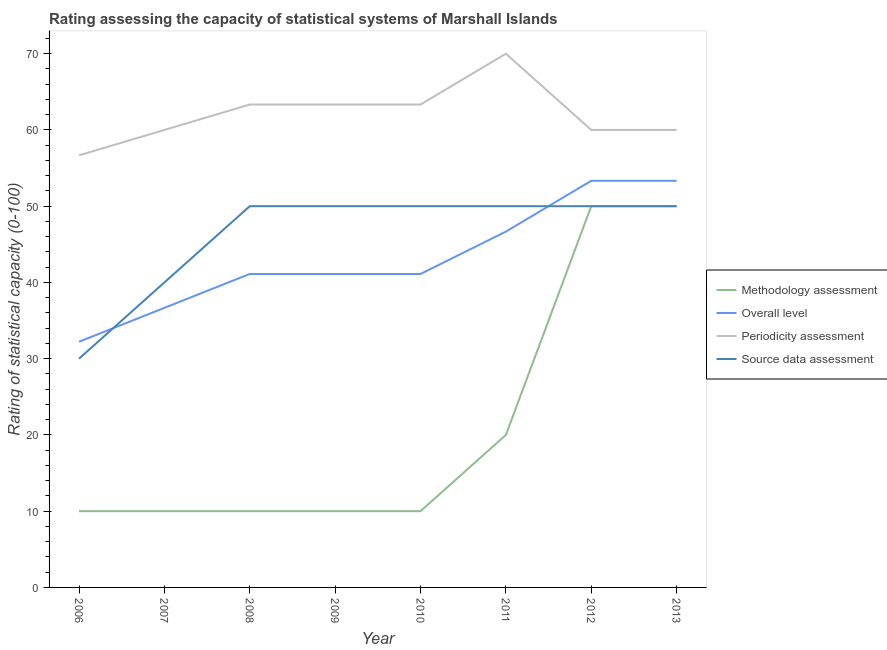Does the line corresponding to methodology assessment rating intersect with the line corresponding to overall level rating?
Ensure brevity in your answer.  No. Is the number of lines equal to the number of legend labels?
Your response must be concise. Yes. What is the source data assessment rating in 2009?
Your response must be concise. 50. Across all years, what is the maximum source data assessment rating?
Provide a short and direct response. 50. Across all years, what is the minimum methodology assessment rating?
Your answer should be very brief. 10. In which year was the source data assessment rating maximum?
Ensure brevity in your answer.  2008. In which year was the periodicity assessment rating minimum?
Offer a terse response. 2006. What is the total overall level rating in the graph?
Your answer should be very brief. 345.56. What is the difference between the overall level rating in 2008 and the periodicity assessment rating in 2010?
Provide a succinct answer. -22.22. What is the average periodicity assessment rating per year?
Give a very brief answer. 62.08. In the year 2007, what is the difference between the source data assessment rating and methodology assessment rating?
Offer a very short reply. 30. What is the ratio of the overall level rating in 2010 to that in 2013?
Offer a terse response. 0.77. Is the overall level rating in 2008 less than that in 2011?
Make the answer very short. Yes. Is the difference between the overall level rating in 2009 and 2012 greater than the difference between the source data assessment rating in 2009 and 2012?
Your response must be concise. No. What is the difference between the highest and the second highest overall level rating?
Your answer should be very brief. 0. What is the difference between the highest and the lowest methodology assessment rating?
Provide a short and direct response. 40. In how many years, is the source data assessment rating greater than the average source data assessment rating taken over all years?
Offer a terse response. 6. Is it the case that in every year, the sum of the overall level rating and periodicity assessment rating is greater than the sum of methodology assessment rating and source data assessment rating?
Offer a terse response. No. How many years are there in the graph?
Your answer should be compact. 8. What is the difference between two consecutive major ticks on the Y-axis?
Ensure brevity in your answer.  10. Are the values on the major ticks of Y-axis written in scientific E-notation?
Make the answer very short. No. Does the graph contain grids?
Provide a short and direct response. No. How are the legend labels stacked?
Provide a short and direct response. Vertical. What is the title of the graph?
Offer a very short reply. Rating assessing the capacity of statistical systems of Marshall Islands. Does "Structural Policies" appear as one of the legend labels in the graph?
Ensure brevity in your answer.  No. What is the label or title of the X-axis?
Make the answer very short. Year. What is the label or title of the Y-axis?
Offer a very short reply. Rating of statistical capacity (0-100). What is the Rating of statistical capacity (0-100) of Overall level in 2006?
Offer a very short reply. 32.22. What is the Rating of statistical capacity (0-100) of Periodicity assessment in 2006?
Ensure brevity in your answer.  56.67. What is the Rating of statistical capacity (0-100) of Overall level in 2007?
Your answer should be very brief. 36.67. What is the Rating of statistical capacity (0-100) of Overall level in 2008?
Make the answer very short. 41.11. What is the Rating of statistical capacity (0-100) in Periodicity assessment in 2008?
Give a very brief answer. 63.33. What is the Rating of statistical capacity (0-100) in Source data assessment in 2008?
Your answer should be very brief. 50. What is the Rating of statistical capacity (0-100) of Methodology assessment in 2009?
Your response must be concise. 10. What is the Rating of statistical capacity (0-100) in Overall level in 2009?
Ensure brevity in your answer.  41.11. What is the Rating of statistical capacity (0-100) of Periodicity assessment in 2009?
Provide a succinct answer. 63.33. What is the Rating of statistical capacity (0-100) in Source data assessment in 2009?
Your answer should be compact. 50. What is the Rating of statistical capacity (0-100) in Methodology assessment in 2010?
Provide a short and direct response. 10. What is the Rating of statistical capacity (0-100) of Overall level in 2010?
Ensure brevity in your answer.  41.11. What is the Rating of statistical capacity (0-100) of Periodicity assessment in 2010?
Provide a succinct answer. 63.33. What is the Rating of statistical capacity (0-100) in Overall level in 2011?
Provide a short and direct response. 46.67. What is the Rating of statistical capacity (0-100) in Periodicity assessment in 2011?
Your response must be concise. 70. What is the Rating of statistical capacity (0-100) of Source data assessment in 2011?
Provide a succinct answer. 50. What is the Rating of statistical capacity (0-100) of Overall level in 2012?
Ensure brevity in your answer.  53.33. What is the Rating of statistical capacity (0-100) in Overall level in 2013?
Your answer should be compact. 53.33. What is the Rating of statistical capacity (0-100) in Source data assessment in 2013?
Give a very brief answer. 50. Across all years, what is the maximum Rating of statistical capacity (0-100) of Methodology assessment?
Give a very brief answer. 50. Across all years, what is the maximum Rating of statistical capacity (0-100) of Overall level?
Your response must be concise. 53.33. Across all years, what is the maximum Rating of statistical capacity (0-100) of Periodicity assessment?
Your answer should be compact. 70. Across all years, what is the minimum Rating of statistical capacity (0-100) in Overall level?
Provide a succinct answer. 32.22. Across all years, what is the minimum Rating of statistical capacity (0-100) of Periodicity assessment?
Offer a very short reply. 56.67. What is the total Rating of statistical capacity (0-100) of Methodology assessment in the graph?
Your response must be concise. 170. What is the total Rating of statistical capacity (0-100) of Overall level in the graph?
Keep it short and to the point. 345.56. What is the total Rating of statistical capacity (0-100) in Periodicity assessment in the graph?
Offer a very short reply. 496.67. What is the total Rating of statistical capacity (0-100) in Source data assessment in the graph?
Give a very brief answer. 370. What is the difference between the Rating of statistical capacity (0-100) in Overall level in 2006 and that in 2007?
Your answer should be very brief. -4.44. What is the difference between the Rating of statistical capacity (0-100) of Periodicity assessment in 2006 and that in 2007?
Offer a terse response. -3.33. What is the difference between the Rating of statistical capacity (0-100) in Source data assessment in 2006 and that in 2007?
Ensure brevity in your answer.  -10. What is the difference between the Rating of statistical capacity (0-100) in Overall level in 2006 and that in 2008?
Provide a succinct answer. -8.89. What is the difference between the Rating of statistical capacity (0-100) in Periodicity assessment in 2006 and that in 2008?
Your response must be concise. -6.67. What is the difference between the Rating of statistical capacity (0-100) in Methodology assessment in 2006 and that in 2009?
Provide a short and direct response. 0. What is the difference between the Rating of statistical capacity (0-100) in Overall level in 2006 and that in 2009?
Offer a very short reply. -8.89. What is the difference between the Rating of statistical capacity (0-100) of Periodicity assessment in 2006 and that in 2009?
Your answer should be compact. -6.67. What is the difference between the Rating of statistical capacity (0-100) in Methodology assessment in 2006 and that in 2010?
Give a very brief answer. 0. What is the difference between the Rating of statistical capacity (0-100) in Overall level in 2006 and that in 2010?
Offer a very short reply. -8.89. What is the difference between the Rating of statistical capacity (0-100) of Periodicity assessment in 2006 and that in 2010?
Keep it short and to the point. -6.67. What is the difference between the Rating of statistical capacity (0-100) of Source data assessment in 2006 and that in 2010?
Keep it short and to the point. -20. What is the difference between the Rating of statistical capacity (0-100) of Methodology assessment in 2006 and that in 2011?
Your answer should be compact. -10. What is the difference between the Rating of statistical capacity (0-100) in Overall level in 2006 and that in 2011?
Offer a terse response. -14.44. What is the difference between the Rating of statistical capacity (0-100) in Periodicity assessment in 2006 and that in 2011?
Provide a short and direct response. -13.33. What is the difference between the Rating of statistical capacity (0-100) of Source data assessment in 2006 and that in 2011?
Keep it short and to the point. -20. What is the difference between the Rating of statistical capacity (0-100) of Methodology assessment in 2006 and that in 2012?
Ensure brevity in your answer.  -40. What is the difference between the Rating of statistical capacity (0-100) of Overall level in 2006 and that in 2012?
Make the answer very short. -21.11. What is the difference between the Rating of statistical capacity (0-100) of Source data assessment in 2006 and that in 2012?
Your response must be concise. -20. What is the difference between the Rating of statistical capacity (0-100) in Overall level in 2006 and that in 2013?
Make the answer very short. -21.11. What is the difference between the Rating of statistical capacity (0-100) in Periodicity assessment in 2006 and that in 2013?
Offer a very short reply. -3.33. What is the difference between the Rating of statistical capacity (0-100) in Overall level in 2007 and that in 2008?
Keep it short and to the point. -4.44. What is the difference between the Rating of statistical capacity (0-100) of Periodicity assessment in 2007 and that in 2008?
Ensure brevity in your answer.  -3.33. What is the difference between the Rating of statistical capacity (0-100) of Methodology assessment in 2007 and that in 2009?
Give a very brief answer. 0. What is the difference between the Rating of statistical capacity (0-100) of Overall level in 2007 and that in 2009?
Your answer should be compact. -4.44. What is the difference between the Rating of statistical capacity (0-100) of Periodicity assessment in 2007 and that in 2009?
Offer a terse response. -3.33. What is the difference between the Rating of statistical capacity (0-100) of Source data assessment in 2007 and that in 2009?
Your answer should be very brief. -10. What is the difference between the Rating of statistical capacity (0-100) in Overall level in 2007 and that in 2010?
Your response must be concise. -4.44. What is the difference between the Rating of statistical capacity (0-100) of Periodicity assessment in 2007 and that in 2010?
Your answer should be very brief. -3.33. What is the difference between the Rating of statistical capacity (0-100) in Source data assessment in 2007 and that in 2010?
Provide a short and direct response. -10. What is the difference between the Rating of statistical capacity (0-100) of Overall level in 2007 and that in 2011?
Your answer should be very brief. -10. What is the difference between the Rating of statistical capacity (0-100) in Periodicity assessment in 2007 and that in 2011?
Keep it short and to the point. -10. What is the difference between the Rating of statistical capacity (0-100) in Source data assessment in 2007 and that in 2011?
Give a very brief answer. -10. What is the difference between the Rating of statistical capacity (0-100) of Overall level in 2007 and that in 2012?
Your answer should be compact. -16.67. What is the difference between the Rating of statistical capacity (0-100) of Periodicity assessment in 2007 and that in 2012?
Your answer should be compact. 0. What is the difference between the Rating of statistical capacity (0-100) in Overall level in 2007 and that in 2013?
Keep it short and to the point. -16.67. What is the difference between the Rating of statistical capacity (0-100) of Methodology assessment in 2008 and that in 2009?
Provide a succinct answer. 0. What is the difference between the Rating of statistical capacity (0-100) of Source data assessment in 2008 and that in 2009?
Your response must be concise. 0. What is the difference between the Rating of statistical capacity (0-100) in Methodology assessment in 2008 and that in 2011?
Give a very brief answer. -10. What is the difference between the Rating of statistical capacity (0-100) in Overall level in 2008 and that in 2011?
Provide a short and direct response. -5.56. What is the difference between the Rating of statistical capacity (0-100) of Periodicity assessment in 2008 and that in 2011?
Ensure brevity in your answer.  -6.67. What is the difference between the Rating of statistical capacity (0-100) in Source data assessment in 2008 and that in 2011?
Ensure brevity in your answer.  0. What is the difference between the Rating of statistical capacity (0-100) in Methodology assessment in 2008 and that in 2012?
Your answer should be very brief. -40. What is the difference between the Rating of statistical capacity (0-100) in Overall level in 2008 and that in 2012?
Make the answer very short. -12.22. What is the difference between the Rating of statistical capacity (0-100) of Overall level in 2008 and that in 2013?
Your answer should be compact. -12.22. What is the difference between the Rating of statistical capacity (0-100) of Periodicity assessment in 2008 and that in 2013?
Your response must be concise. 3.33. What is the difference between the Rating of statistical capacity (0-100) in Source data assessment in 2008 and that in 2013?
Ensure brevity in your answer.  0. What is the difference between the Rating of statistical capacity (0-100) in Overall level in 2009 and that in 2010?
Give a very brief answer. 0. What is the difference between the Rating of statistical capacity (0-100) in Methodology assessment in 2009 and that in 2011?
Your answer should be very brief. -10. What is the difference between the Rating of statistical capacity (0-100) in Overall level in 2009 and that in 2011?
Provide a succinct answer. -5.56. What is the difference between the Rating of statistical capacity (0-100) in Periodicity assessment in 2009 and that in 2011?
Provide a short and direct response. -6.67. What is the difference between the Rating of statistical capacity (0-100) of Overall level in 2009 and that in 2012?
Your response must be concise. -12.22. What is the difference between the Rating of statistical capacity (0-100) in Periodicity assessment in 2009 and that in 2012?
Give a very brief answer. 3.33. What is the difference between the Rating of statistical capacity (0-100) in Methodology assessment in 2009 and that in 2013?
Ensure brevity in your answer.  -40. What is the difference between the Rating of statistical capacity (0-100) in Overall level in 2009 and that in 2013?
Make the answer very short. -12.22. What is the difference between the Rating of statistical capacity (0-100) in Source data assessment in 2009 and that in 2013?
Offer a very short reply. 0. What is the difference between the Rating of statistical capacity (0-100) of Methodology assessment in 2010 and that in 2011?
Offer a very short reply. -10. What is the difference between the Rating of statistical capacity (0-100) in Overall level in 2010 and that in 2011?
Offer a very short reply. -5.56. What is the difference between the Rating of statistical capacity (0-100) in Periodicity assessment in 2010 and that in 2011?
Your response must be concise. -6.67. What is the difference between the Rating of statistical capacity (0-100) of Source data assessment in 2010 and that in 2011?
Your answer should be very brief. 0. What is the difference between the Rating of statistical capacity (0-100) in Overall level in 2010 and that in 2012?
Provide a short and direct response. -12.22. What is the difference between the Rating of statistical capacity (0-100) in Periodicity assessment in 2010 and that in 2012?
Offer a very short reply. 3.33. What is the difference between the Rating of statistical capacity (0-100) of Source data assessment in 2010 and that in 2012?
Your response must be concise. 0. What is the difference between the Rating of statistical capacity (0-100) of Methodology assessment in 2010 and that in 2013?
Offer a very short reply. -40. What is the difference between the Rating of statistical capacity (0-100) in Overall level in 2010 and that in 2013?
Provide a short and direct response. -12.22. What is the difference between the Rating of statistical capacity (0-100) in Periodicity assessment in 2010 and that in 2013?
Provide a short and direct response. 3.33. What is the difference between the Rating of statistical capacity (0-100) in Overall level in 2011 and that in 2012?
Offer a very short reply. -6.67. What is the difference between the Rating of statistical capacity (0-100) in Source data assessment in 2011 and that in 2012?
Make the answer very short. 0. What is the difference between the Rating of statistical capacity (0-100) in Methodology assessment in 2011 and that in 2013?
Offer a terse response. -30. What is the difference between the Rating of statistical capacity (0-100) of Overall level in 2011 and that in 2013?
Your answer should be very brief. -6.67. What is the difference between the Rating of statistical capacity (0-100) of Source data assessment in 2012 and that in 2013?
Your answer should be very brief. 0. What is the difference between the Rating of statistical capacity (0-100) of Methodology assessment in 2006 and the Rating of statistical capacity (0-100) of Overall level in 2007?
Keep it short and to the point. -26.67. What is the difference between the Rating of statistical capacity (0-100) of Methodology assessment in 2006 and the Rating of statistical capacity (0-100) of Periodicity assessment in 2007?
Provide a short and direct response. -50. What is the difference between the Rating of statistical capacity (0-100) in Methodology assessment in 2006 and the Rating of statistical capacity (0-100) in Source data assessment in 2007?
Provide a succinct answer. -30. What is the difference between the Rating of statistical capacity (0-100) of Overall level in 2006 and the Rating of statistical capacity (0-100) of Periodicity assessment in 2007?
Make the answer very short. -27.78. What is the difference between the Rating of statistical capacity (0-100) in Overall level in 2006 and the Rating of statistical capacity (0-100) in Source data assessment in 2007?
Ensure brevity in your answer.  -7.78. What is the difference between the Rating of statistical capacity (0-100) of Periodicity assessment in 2006 and the Rating of statistical capacity (0-100) of Source data assessment in 2007?
Your answer should be compact. 16.67. What is the difference between the Rating of statistical capacity (0-100) of Methodology assessment in 2006 and the Rating of statistical capacity (0-100) of Overall level in 2008?
Your answer should be very brief. -31.11. What is the difference between the Rating of statistical capacity (0-100) of Methodology assessment in 2006 and the Rating of statistical capacity (0-100) of Periodicity assessment in 2008?
Offer a very short reply. -53.33. What is the difference between the Rating of statistical capacity (0-100) in Overall level in 2006 and the Rating of statistical capacity (0-100) in Periodicity assessment in 2008?
Ensure brevity in your answer.  -31.11. What is the difference between the Rating of statistical capacity (0-100) in Overall level in 2006 and the Rating of statistical capacity (0-100) in Source data assessment in 2008?
Provide a short and direct response. -17.78. What is the difference between the Rating of statistical capacity (0-100) of Methodology assessment in 2006 and the Rating of statistical capacity (0-100) of Overall level in 2009?
Offer a terse response. -31.11. What is the difference between the Rating of statistical capacity (0-100) in Methodology assessment in 2006 and the Rating of statistical capacity (0-100) in Periodicity assessment in 2009?
Offer a very short reply. -53.33. What is the difference between the Rating of statistical capacity (0-100) of Methodology assessment in 2006 and the Rating of statistical capacity (0-100) of Source data assessment in 2009?
Your answer should be very brief. -40. What is the difference between the Rating of statistical capacity (0-100) of Overall level in 2006 and the Rating of statistical capacity (0-100) of Periodicity assessment in 2009?
Your answer should be very brief. -31.11. What is the difference between the Rating of statistical capacity (0-100) of Overall level in 2006 and the Rating of statistical capacity (0-100) of Source data assessment in 2009?
Your answer should be compact. -17.78. What is the difference between the Rating of statistical capacity (0-100) in Methodology assessment in 2006 and the Rating of statistical capacity (0-100) in Overall level in 2010?
Keep it short and to the point. -31.11. What is the difference between the Rating of statistical capacity (0-100) of Methodology assessment in 2006 and the Rating of statistical capacity (0-100) of Periodicity assessment in 2010?
Your answer should be very brief. -53.33. What is the difference between the Rating of statistical capacity (0-100) in Methodology assessment in 2006 and the Rating of statistical capacity (0-100) in Source data assessment in 2010?
Give a very brief answer. -40. What is the difference between the Rating of statistical capacity (0-100) of Overall level in 2006 and the Rating of statistical capacity (0-100) of Periodicity assessment in 2010?
Keep it short and to the point. -31.11. What is the difference between the Rating of statistical capacity (0-100) of Overall level in 2006 and the Rating of statistical capacity (0-100) of Source data assessment in 2010?
Offer a very short reply. -17.78. What is the difference between the Rating of statistical capacity (0-100) of Periodicity assessment in 2006 and the Rating of statistical capacity (0-100) of Source data assessment in 2010?
Your answer should be very brief. 6.67. What is the difference between the Rating of statistical capacity (0-100) in Methodology assessment in 2006 and the Rating of statistical capacity (0-100) in Overall level in 2011?
Provide a short and direct response. -36.67. What is the difference between the Rating of statistical capacity (0-100) of Methodology assessment in 2006 and the Rating of statistical capacity (0-100) of Periodicity assessment in 2011?
Offer a terse response. -60. What is the difference between the Rating of statistical capacity (0-100) in Overall level in 2006 and the Rating of statistical capacity (0-100) in Periodicity assessment in 2011?
Ensure brevity in your answer.  -37.78. What is the difference between the Rating of statistical capacity (0-100) of Overall level in 2006 and the Rating of statistical capacity (0-100) of Source data assessment in 2011?
Make the answer very short. -17.78. What is the difference between the Rating of statistical capacity (0-100) of Periodicity assessment in 2006 and the Rating of statistical capacity (0-100) of Source data assessment in 2011?
Give a very brief answer. 6.67. What is the difference between the Rating of statistical capacity (0-100) in Methodology assessment in 2006 and the Rating of statistical capacity (0-100) in Overall level in 2012?
Keep it short and to the point. -43.33. What is the difference between the Rating of statistical capacity (0-100) in Methodology assessment in 2006 and the Rating of statistical capacity (0-100) in Periodicity assessment in 2012?
Ensure brevity in your answer.  -50. What is the difference between the Rating of statistical capacity (0-100) of Methodology assessment in 2006 and the Rating of statistical capacity (0-100) of Source data assessment in 2012?
Offer a terse response. -40. What is the difference between the Rating of statistical capacity (0-100) of Overall level in 2006 and the Rating of statistical capacity (0-100) of Periodicity assessment in 2012?
Your answer should be very brief. -27.78. What is the difference between the Rating of statistical capacity (0-100) in Overall level in 2006 and the Rating of statistical capacity (0-100) in Source data assessment in 2012?
Provide a succinct answer. -17.78. What is the difference between the Rating of statistical capacity (0-100) of Periodicity assessment in 2006 and the Rating of statistical capacity (0-100) of Source data assessment in 2012?
Provide a succinct answer. 6.67. What is the difference between the Rating of statistical capacity (0-100) in Methodology assessment in 2006 and the Rating of statistical capacity (0-100) in Overall level in 2013?
Your answer should be compact. -43.33. What is the difference between the Rating of statistical capacity (0-100) in Methodology assessment in 2006 and the Rating of statistical capacity (0-100) in Source data assessment in 2013?
Provide a short and direct response. -40. What is the difference between the Rating of statistical capacity (0-100) of Overall level in 2006 and the Rating of statistical capacity (0-100) of Periodicity assessment in 2013?
Offer a very short reply. -27.78. What is the difference between the Rating of statistical capacity (0-100) in Overall level in 2006 and the Rating of statistical capacity (0-100) in Source data assessment in 2013?
Your answer should be very brief. -17.78. What is the difference between the Rating of statistical capacity (0-100) of Methodology assessment in 2007 and the Rating of statistical capacity (0-100) of Overall level in 2008?
Offer a terse response. -31.11. What is the difference between the Rating of statistical capacity (0-100) in Methodology assessment in 2007 and the Rating of statistical capacity (0-100) in Periodicity assessment in 2008?
Your answer should be compact. -53.33. What is the difference between the Rating of statistical capacity (0-100) in Methodology assessment in 2007 and the Rating of statistical capacity (0-100) in Source data assessment in 2008?
Give a very brief answer. -40. What is the difference between the Rating of statistical capacity (0-100) of Overall level in 2007 and the Rating of statistical capacity (0-100) of Periodicity assessment in 2008?
Offer a very short reply. -26.67. What is the difference between the Rating of statistical capacity (0-100) in Overall level in 2007 and the Rating of statistical capacity (0-100) in Source data assessment in 2008?
Your answer should be very brief. -13.33. What is the difference between the Rating of statistical capacity (0-100) of Methodology assessment in 2007 and the Rating of statistical capacity (0-100) of Overall level in 2009?
Provide a short and direct response. -31.11. What is the difference between the Rating of statistical capacity (0-100) of Methodology assessment in 2007 and the Rating of statistical capacity (0-100) of Periodicity assessment in 2009?
Your response must be concise. -53.33. What is the difference between the Rating of statistical capacity (0-100) in Methodology assessment in 2007 and the Rating of statistical capacity (0-100) in Source data assessment in 2009?
Your response must be concise. -40. What is the difference between the Rating of statistical capacity (0-100) in Overall level in 2007 and the Rating of statistical capacity (0-100) in Periodicity assessment in 2009?
Make the answer very short. -26.67. What is the difference between the Rating of statistical capacity (0-100) of Overall level in 2007 and the Rating of statistical capacity (0-100) of Source data assessment in 2009?
Provide a short and direct response. -13.33. What is the difference between the Rating of statistical capacity (0-100) of Periodicity assessment in 2007 and the Rating of statistical capacity (0-100) of Source data assessment in 2009?
Provide a short and direct response. 10. What is the difference between the Rating of statistical capacity (0-100) of Methodology assessment in 2007 and the Rating of statistical capacity (0-100) of Overall level in 2010?
Ensure brevity in your answer.  -31.11. What is the difference between the Rating of statistical capacity (0-100) of Methodology assessment in 2007 and the Rating of statistical capacity (0-100) of Periodicity assessment in 2010?
Your response must be concise. -53.33. What is the difference between the Rating of statistical capacity (0-100) of Methodology assessment in 2007 and the Rating of statistical capacity (0-100) of Source data assessment in 2010?
Provide a short and direct response. -40. What is the difference between the Rating of statistical capacity (0-100) of Overall level in 2007 and the Rating of statistical capacity (0-100) of Periodicity assessment in 2010?
Give a very brief answer. -26.67. What is the difference between the Rating of statistical capacity (0-100) in Overall level in 2007 and the Rating of statistical capacity (0-100) in Source data assessment in 2010?
Provide a succinct answer. -13.33. What is the difference between the Rating of statistical capacity (0-100) in Methodology assessment in 2007 and the Rating of statistical capacity (0-100) in Overall level in 2011?
Your response must be concise. -36.67. What is the difference between the Rating of statistical capacity (0-100) of Methodology assessment in 2007 and the Rating of statistical capacity (0-100) of Periodicity assessment in 2011?
Offer a very short reply. -60. What is the difference between the Rating of statistical capacity (0-100) in Overall level in 2007 and the Rating of statistical capacity (0-100) in Periodicity assessment in 2011?
Ensure brevity in your answer.  -33.33. What is the difference between the Rating of statistical capacity (0-100) of Overall level in 2007 and the Rating of statistical capacity (0-100) of Source data assessment in 2011?
Keep it short and to the point. -13.33. What is the difference between the Rating of statistical capacity (0-100) of Methodology assessment in 2007 and the Rating of statistical capacity (0-100) of Overall level in 2012?
Ensure brevity in your answer.  -43.33. What is the difference between the Rating of statistical capacity (0-100) of Overall level in 2007 and the Rating of statistical capacity (0-100) of Periodicity assessment in 2012?
Your response must be concise. -23.33. What is the difference between the Rating of statistical capacity (0-100) of Overall level in 2007 and the Rating of statistical capacity (0-100) of Source data assessment in 2012?
Your answer should be very brief. -13.33. What is the difference between the Rating of statistical capacity (0-100) of Periodicity assessment in 2007 and the Rating of statistical capacity (0-100) of Source data assessment in 2012?
Keep it short and to the point. 10. What is the difference between the Rating of statistical capacity (0-100) in Methodology assessment in 2007 and the Rating of statistical capacity (0-100) in Overall level in 2013?
Provide a succinct answer. -43.33. What is the difference between the Rating of statistical capacity (0-100) in Methodology assessment in 2007 and the Rating of statistical capacity (0-100) in Periodicity assessment in 2013?
Your answer should be very brief. -50. What is the difference between the Rating of statistical capacity (0-100) in Overall level in 2007 and the Rating of statistical capacity (0-100) in Periodicity assessment in 2013?
Your response must be concise. -23.33. What is the difference between the Rating of statistical capacity (0-100) in Overall level in 2007 and the Rating of statistical capacity (0-100) in Source data assessment in 2013?
Keep it short and to the point. -13.33. What is the difference between the Rating of statistical capacity (0-100) in Methodology assessment in 2008 and the Rating of statistical capacity (0-100) in Overall level in 2009?
Your answer should be compact. -31.11. What is the difference between the Rating of statistical capacity (0-100) in Methodology assessment in 2008 and the Rating of statistical capacity (0-100) in Periodicity assessment in 2009?
Your response must be concise. -53.33. What is the difference between the Rating of statistical capacity (0-100) of Methodology assessment in 2008 and the Rating of statistical capacity (0-100) of Source data assessment in 2009?
Ensure brevity in your answer.  -40. What is the difference between the Rating of statistical capacity (0-100) of Overall level in 2008 and the Rating of statistical capacity (0-100) of Periodicity assessment in 2009?
Your answer should be compact. -22.22. What is the difference between the Rating of statistical capacity (0-100) in Overall level in 2008 and the Rating of statistical capacity (0-100) in Source data assessment in 2009?
Make the answer very short. -8.89. What is the difference between the Rating of statistical capacity (0-100) of Periodicity assessment in 2008 and the Rating of statistical capacity (0-100) of Source data assessment in 2009?
Offer a terse response. 13.33. What is the difference between the Rating of statistical capacity (0-100) in Methodology assessment in 2008 and the Rating of statistical capacity (0-100) in Overall level in 2010?
Offer a terse response. -31.11. What is the difference between the Rating of statistical capacity (0-100) of Methodology assessment in 2008 and the Rating of statistical capacity (0-100) of Periodicity assessment in 2010?
Your answer should be very brief. -53.33. What is the difference between the Rating of statistical capacity (0-100) of Methodology assessment in 2008 and the Rating of statistical capacity (0-100) of Source data assessment in 2010?
Ensure brevity in your answer.  -40. What is the difference between the Rating of statistical capacity (0-100) in Overall level in 2008 and the Rating of statistical capacity (0-100) in Periodicity assessment in 2010?
Ensure brevity in your answer.  -22.22. What is the difference between the Rating of statistical capacity (0-100) of Overall level in 2008 and the Rating of statistical capacity (0-100) of Source data assessment in 2010?
Keep it short and to the point. -8.89. What is the difference between the Rating of statistical capacity (0-100) of Periodicity assessment in 2008 and the Rating of statistical capacity (0-100) of Source data assessment in 2010?
Make the answer very short. 13.33. What is the difference between the Rating of statistical capacity (0-100) in Methodology assessment in 2008 and the Rating of statistical capacity (0-100) in Overall level in 2011?
Your response must be concise. -36.67. What is the difference between the Rating of statistical capacity (0-100) in Methodology assessment in 2008 and the Rating of statistical capacity (0-100) in Periodicity assessment in 2011?
Your answer should be compact. -60. What is the difference between the Rating of statistical capacity (0-100) of Methodology assessment in 2008 and the Rating of statistical capacity (0-100) of Source data assessment in 2011?
Your response must be concise. -40. What is the difference between the Rating of statistical capacity (0-100) in Overall level in 2008 and the Rating of statistical capacity (0-100) in Periodicity assessment in 2011?
Keep it short and to the point. -28.89. What is the difference between the Rating of statistical capacity (0-100) in Overall level in 2008 and the Rating of statistical capacity (0-100) in Source data assessment in 2011?
Your answer should be very brief. -8.89. What is the difference between the Rating of statistical capacity (0-100) of Periodicity assessment in 2008 and the Rating of statistical capacity (0-100) of Source data assessment in 2011?
Give a very brief answer. 13.33. What is the difference between the Rating of statistical capacity (0-100) of Methodology assessment in 2008 and the Rating of statistical capacity (0-100) of Overall level in 2012?
Ensure brevity in your answer.  -43.33. What is the difference between the Rating of statistical capacity (0-100) of Methodology assessment in 2008 and the Rating of statistical capacity (0-100) of Source data assessment in 2012?
Your answer should be compact. -40. What is the difference between the Rating of statistical capacity (0-100) in Overall level in 2008 and the Rating of statistical capacity (0-100) in Periodicity assessment in 2012?
Ensure brevity in your answer.  -18.89. What is the difference between the Rating of statistical capacity (0-100) of Overall level in 2008 and the Rating of statistical capacity (0-100) of Source data assessment in 2012?
Make the answer very short. -8.89. What is the difference between the Rating of statistical capacity (0-100) of Periodicity assessment in 2008 and the Rating of statistical capacity (0-100) of Source data assessment in 2012?
Keep it short and to the point. 13.33. What is the difference between the Rating of statistical capacity (0-100) in Methodology assessment in 2008 and the Rating of statistical capacity (0-100) in Overall level in 2013?
Your response must be concise. -43.33. What is the difference between the Rating of statistical capacity (0-100) of Overall level in 2008 and the Rating of statistical capacity (0-100) of Periodicity assessment in 2013?
Your response must be concise. -18.89. What is the difference between the Rating of statistical capacity (0-100) in Overall level in 2008 and the Rating of statistical capacity (0-100) in Source data assessment in 2013?
Offer a very short reply. -8.89. What is the difference between the Rating of statistical capacity (0-100) in Periodicity assessment in 2008 and the Rating of statistical capacity (0-100) in Source data assessment in 2013?
Make the answer very short. 13.33. What is the difference between the Rating of statistical capacity (0-100) in Methodology assessment in 2009 and the Rating of statistical capacity (0-100) in Overall level in 2010?
Keep it short and to the point. -31.11. What is the difference between the Rating of statistical capacity (0-100) of Methodology assessment in 2009 and the Rating of statistical capacity (0-100) of Periodicity assessment in 2010?
Your answer should be compact. -53.33. What is the difference between the Rating of statistical capacity (0-100) of Overall level in 2009 and the Rating of statistical capacity (0-100) of Periodicity assessment in 2010?
Ensure brevity in your answer.  -22.22. What is the difference between the Rating of statistical capacity (0-100) in Overall level in 2009 and the Rating of statistical capacity (0-100) in Source data assessment in 2010?
Give a very brief answer. -8.89. What is the difference between the Rating of statistical capacity (0-100) in Periodicity assessment in 2009 and the Rating of statistical capacity (0-100) in Source data assessment in 2010?
Offer a terse response. 13.33. What is the difference between the Rating of statistical capacity (0-100) of Methodology assessment in 2009 and the Rating of statistical capacity (0-100) of Overall level in 2011?
Ensure brevity in your answer.  -36.67. What is the difference between the Rating of statistical capacity (0-100) in Methodology assessment in 2009 and the Rating of statistical capacity (0-100) in Periodicity assessment in 2011?
Offer a very short reply. -60. What is the difference between the Rating of statistical capacity (0-100) in Methodology assessment in 2009 and the Rating of statistical capacity (0-100) in Source data assessment in 2011?
Offer a very short reply. -40. What is the difference between the Rating of statistical capacity (0-100) of Overall level in 2009 and the Rating of statistical capacity (0-100) of Periodicity assessment in 2011?
Give a very brief answer. -28.89. What is the difference between the Rating of statistical capacity (0-100) of Overall level in 2009 and the Rating of statistical capacity (0-100) of Source data assessment in 2011?
Give a very brief answer. -8.89. What is the difference between the Rating of statistical capacity (0-100) in Periodicity assessment in 2009 and the Rating of statistical capacity (0-100) in Source data assessment in 2011?
Provide a succinct answer. 13.33. What is the difference between the Rating of statistical capacity (0-100) in Methodology assessment in 2009 and the Rating of statistical capacity (0-100) in Overall level in 2012?
Offer a very short reply. -43.33. What is the difference between the Rating of statistical capacity (0-100) of Methodology assessment in 2009 and the Rating of statistical capacity (0-100) of Periodicity assessment in 2012?
Ensure brevity in your answer.  -50. What is the difference between the Rating of statistical capacity (0-100) of Methodology assessment in 2009 and the Rating of statistical capacity (0-100) of Source data assessment in 2012?
Offer a terse response. -40. What is the difference between the Rating of statistical capacity (0-100) of Overall level in 2009 and the Rating of statistical capacity (0-100) of Periodicity assessment in 2012?
Your answer should be compact. -18.89. What is the difference between the Rating of statistical capacity (0-100) of Overall level in 2009 and the Rating of statistical capacity (0-100) of Source data assessment in 2012?
Offer a very short reply. -8.89. What is the difference between the Rating of statistical capacity (0-100) in Periodicity assessment in 2009 and the Rating of statistical capacity (0-100) in Source data assessment in 2012?
Provide a succinct answer. 13.33. What is the difference between the Rating of statistical capacity (0-100) of Methodology assessment in 2009 and the Rating of statistical capacity (0-100) of Overall level in 2013?
Provide a short and direct response. -43.33. What is the difference between the Rating of statistical capacity (0-100) of Methodology assessment in 2009 and the Rating of statistical capacity (0-100) of Periodicity assessment in 2013?
Offer a terse response. -50. What is the difference between the Rating of statistical capacity (0-100) in Overall level in 2009 and the Rating of statistical capacity (0-100) in Periodicity assessment in 2013?
Your answer should be compact. -18.89. What is the difference between the Rating of statistical capacity (0-100) of Overall level in 2009 and the Rating of statistical capacity (0-100) of Source data assessment in 2013?
Your response must be concise. -8.89. What is the difference between the Rating of statistical capacity (0-100) of Periodicity assessment in 2009 and the Rating of statistical capacity (0-100) of Source data assessment in 2013?
Your answer should be compact. 13.33. What is the difference between the Rating of statistical capacity (0-100) in Methodology assessment in 2010 and the Rating of statistical capacity (0-100) in Overall level in 2011?
Make the answer very short. -36.67. What is the difference between the Rating of statistical capacity (0-100) in Methodology assessment in 2010 and the Rating of statistical capacity (0-100) in Periodicity assessment in 2011?
Make the answer very short. -60. What is the difference between the Rating of statistical capacity (0-100) of Overall level in 2010 and the Rating of statistical capacity (0-100) of Periodicity assessment in 2011?
Your response must be concise. -28.89. What is the difference between the Rating of statistical capacity (0-100) in Overall level in 2010 and the Rating of statistical capacity (0-100) in Source data assessment in 2011?
Give a very brief answer. -8.89. What is the difference between the Rating of statistical capacity (0-100) of Periodicity assessment in 2010 and the Rating of statistical capacity (0-100) of Source data assessment in 2011?
Your answer should be compact. 13.33. What is the difference between the Rating of statistical capacity (0-100) of Methodology assessment in 2010 and the Rating of statistical capacity (0-100) of Overall level in 2012?
Provide a succinct answer. -43.33. What is the difference between the Rating of statistical capacity (0-100) of Methodology assessment in 2010 and the Rating of statistical capacity (0-100) of Source data assessment in 2012?
Your answer should be very brief. -40. What is the difference between the Rating of statistical capacity (0-100) of Overall level in 2010 and the Rating of statistical capacity (0-100) of Periodicity assessment in 2012?
Make the answer very short. -18.89. What is the difference between the Rating of statistical capacity (0-100) in Overall level in 2010 and the Rating of statistical capacity (0-100) in Source data assessment in 2012?
Provide a succinct answer. -8.89. What is the difference between the Rating of statistical capacity (0-100) in Periodicity assessment in 2010 and the Rating of statistical capacity (0-100) in Source data assessment in 2012?
Make the answer very short. 13.33. What is the difference between the Rating of statistical capacity (0-100) in Methodology assessment in 2010 and the Rating of statistical capacity (0-100) in Overall level in 2013?
Give a very brief answer. -43.33. What is the difference between the Rating of statistical capacity (0-100) in Overall level in 2010 and the Rating of statistical capacity (0-100) in Periodicity assessment in 2013?
Provide a short and direct response. -18.89. What is the difference between the Rating of statistical capacity (0-100) in Overall level in 2010 and the Rating of statistical capacity (0-100) in Source data assessment in 2013?
Offer a very short reply. -8.89. What is the difference between the Rating of statistical capacity (0-100) of Periodicity assessment in 2010 and the Rating of statistical capacity (0-100) of Source data assessment in 2013?
Offer a very short reply. 13.33. What is the difference between the Rating of statistical capacity (0-100) in Methodology assessment in 2011 and the Rating of statistical capacity (0-100) in Overall level in 2012?
Your response must be concise. -33.33. What is the difference between the Rating of statistical capacity (0-100) of Methodology assessment in 2011 and the Rating of statistical capacity (0-100) of Periodicity assessment in 2012?
Offer a terse response. -40. What is the difference between the Rating of statistical capacity (0-100) of Overall level in 2011 and the Rating of statistical capacity (0-100) of Periodicity assessment in 2012?
Your response must be concise. -13.33. What is the difference between the Rating of statistical capacity (0-100) of Methodology assessment in 2011 and the Rating of statistical capacity (0-100) of Overall level in 2013?
Your answer should be very brief. -33.33. What is the difference between the Rating of statistical capacity (0-100) of Overall level in 2011 and the Rating of statistical capacity (0-100) of Periodicity assessment in 2013?
Provide a succinct answer. -13.33. What is the difference between the Rating of statistical capacity (0-100) in Overall level in 2011 and the Rating of statistical capacity (0-100) in Source data assessment in 2013?
Keep it short and to the point. -3.33. What is the difference between the Rating of statistical capacity (0-100) in Methodology assessment in 2012 and the Rating of statistical capacity (0-100) in Overall level in 2013?
Offer a terse response. -3.33. What is the difference between the Rating of statistical capacity (0-100) of Methodology assessment in 2012 and the Rating of statistical capacity (0-100) of Periodicity assessment in 2013?
Provide a succinct answer. -10. What is the difference between the Rating of statistical capacity (0-100) in Methodology assessment in 2012 and the Rating of statistical capacity (0-100) in Source data assessment in 2013?
Provide a short and direct response. 0. What is the difference between the Rating of statistical capacity (0-100) of Overall level in 2012 and the Rating of statistical capacity (0-100) of Periodicity assessment in 2013?
Ensure brevity in your answer.  -6.67. What is the difference between the Rating of statistical capacity (0-100) of Periodicity assessment in 2012 and the Rating of statistical capacity (0-100) of Source data assessment in 2013?
Ensure brevity in your answer.  10. What is the average Rating of statistical capacity (0-100) in Methodology assessment per year?
Give a very brief answer. 21.25. What is the average Rating of statistical capacity (0-100) of Overall level per year?
Your answer should be very brief. 43.19. What is the average Rating of statistical capacity (0-100) of Periodicity assessment per year?
Offer a terse response. 62.08. What is the average Rating of statistical capacity (0-100) of Source data assessment per year?
Keep it short and to the point. 46.25. In the year 2006, what is the difference between the Rating of statistical capacity (0-100) in Methodology assessment and Rating of statistical capacity (0-100) in Overall level?
Your answer should be very brief. -22.22. In the year 2006, what is the difference between the Rating of statistical capacity (0-100) in Methodology assessment and Rating of statistical capacity (0-100) in Periodicity assessment?
Your response must be concise. -46.67. In the year 2006, what is the difference between the Rating of statistical capacity (0-100) of Methodology assessment and Rating of statistical capacity (0-100) of Source data assessment?
Your response must be concise. -20. In the year 2006, what is the difference between the Rating of statistical capacity (0-100) in Overall level and Rating of statistical capacity (0-100) in Periodicity assessment?
Provide a succinct answer. -24.44. In the year 2006, what is the difference between the Rating of statistical capacity (0-100) in Overall level and Rating of statistical capacity (0-100) in Source data assessment?
Offer a terse response. 2.22. In the year 2006, what is the difference between the Rating of statistical capacity (0-100) of Periodicity assessment and Rating of statistical capacity (0-100) of Source data assessment?
Provide a short and direct response. 26.67. In the year 2007, what is the difference between the Rating of statistical capacity (0-100) in Methodology assessment and Rating of statistical capacity (0-100) in Overall level?
Keep it short and to the point. -26.67. In the year 2007, what is the difference between the Rating of statistical capacity (0-100) in Methodology assessment and Rating of statistical capacity (0-100) in Periodicity assessment?
Provide a short and direct response. -50. In the year 2007, what is the difference between the Rating of statistical capacity (0-100) of Overall level and Rating of statistical capacity (0-100) of Periodicity assessment?
Provide a short and direct response. -23.33. In the year 2007, what is the difference between the Rating of statistical capacity (0-100) of Overall level and Rating of statistical capacity (0-100) of Source data assessment?
Ensure brevity in your answer.  -3.33. In the year 2007, what is the difference between the Rating of statistical capacity (0-100) in Periodicity assessment and Rating of statistical capacity (0-100) in Source data assessment?
Offer a very short reply. 20. In the year 2008, what is the difference between the Rating of statistical capacity (0-100) of Methodology assessment and Rating of statistical capacity (0-100) of Overall level?
Your answer should be compact. -31.11. In the year 2008, what is the difference between the Rating of statistical capacity (0-100) in Methodology assessment and Rating of statistical capacity (0-100) in Periodicity assessment?
Your answer should be very brief. -53.33. In the year 2008, what is the difference between the Rating of statistical capacity (0-100) in Methodology assessment and Rating of statistical capacity (0-100) in Source data assessment?
Keep it short and to the point. -40. In the year 2008, what is the difference between the Rating of statistical capacity (0-100) in Overall level and Rating of statistical capacity (0-100) in Periodicity assessment?
Your answer should be compact. -22.22. In the year 2008, what is the difference between the Rating of statistical capacity (0-100) of Overall level and Rating of statistical capacity (0-100) of Source data assessment?
Your response must be concise. -8.89. In the year 2008, what is the difference between the Rating of statistical capacity (0-100) of Periodicity assessment and Rating of statistical capacity (0-100) of Source data assessment?
Provide a succinct answer. 13.33. In the year 2009, what is the difference between the Rating of statistical capacity (0-100) of Methodology assessment and Rating of statistical capacity (0-100) of Overall level?
Ensure brevity in your answer.  -31.11. In the year 2009, what is the difference between the Rating of statistical capacity (0-100) of Methodology assessment and Rating of statistical capacity (0-100) of Periodicity assessment?
Provide a succinct answer. -53.33. In the year 2009, what is the difference between the Rating of statistical capacity (0-100) in Methodology assessment and Rating of statistical capacity (0-100) in Source data assessment?
Make the answer very short. -40. In the year 2009, what is the difference between the Rating of statistical capacity (0-100) of Overall level and Rating of statistical capacity (0-100) of Periodicity assessment?
Offer a terse response. -22.22. In the year 2009, what is the difference between the Rating of statistical capacity (0-100) in Overall level and Rating of statistical capacity (0-100) in Source data assessment?
Give a very brief answer. -8.89. In the year 2009, what is the difference between the Rating of statistical capacity (0-100) of Periodicity assessment and Rating of statistical capacity (0-100) of Source data assessment?
Make the answer very short. 13.33. In the year 2010, what is the difference between the Rating of statistical capacity (0-100) of Methodology assessment and Rating of statistical capacity (0-100) of Overall level?
Give a very brief answer. -31.11. In the year 2010, what is the difference between the Rating of statistical capacity (0-100) in Methodology assessment and Rating of statistical capacity (0-100) in Periodicity assessment?
Make the answer very short. -53.33. In the year 2010, what is the difference between the Rating of statistical capacity (0-100) of Methodology assessment and Rating of statistical capacity (0-100) of Source data assessment?
Your answer should be very brief. -40. In the year 2010, what is the difference between the Rating of statistical capacity (0-100) in Overall level and Rating of statistical capacity (0-100) in Periodicity assessment?
Offer a terse response. -22.22. In the year 2010, what is the difference between the Rating of statistical capacity (0-100) of Overall level and Rating of statistical capacity (0-100) of Source data assessment?
Your answer should be very brief. -8.89. In the year 2010, what is the difference between the Rating of statistical capacity (0-100) in Periodicity assessment and Rating of statistical capacity (0-100) in Source data assessment?
Give a very brief answer. 13.33. In the year 2011, what is the difference between the Rating of statistical capacity (0-100) in Methodology assessment and Rating of statistical capacity (0-100) in Overall level?
Provide a short and direct response. -26.67. In the year 2011, what is the difference between the Rating of statistical capacity (0-100) in Methodology assessment and Rating of statistical capacity (0-100) in Periodicity assessment?
Give a very brief answer. -50. In the year 2011, what is the difference between the Rating of statistical capacity (0-100) of Methodology assessment and Rating of statistical capacity (0-100) of Source data assessment?
Make the answer very short. -30. In the year 2011, what is the difference between the Rating of statistical capacity (0-100) of Overall level and Rating of statistical capacity (0-100) of Periodicity assessment?
Make the answer very short. -23.33. In the year 2011, what is the difference between the Rating of statistical capacity (0-100) in Periodicity assessment and Rating of statistical capacity (0-100) in Source data assessment?
Keep it short and to the point. 20. In the year 2012, what is the difference between the Rating of statistical capacity (0-100) in Methodology assessment and Rating of statistical capacity (0-100) in Overall level?
Your answer should be compact. -3.33. In the year 2012, what is the difference between the Rating of statistical capacity (0-100) of Methodology assessment and Rating of statistical capacity (0-100) of Periodicity assessment?
Offer a very short reply. -10. In the year 2012, what is the difference between the Rating of statistical capacity (0-100) of Overall level and Rating of statistical capacity (0-100) of Periodicity assessment?
Your answer should be compact. -6.67. In the year 2013, what is the difference between the Rating of statistical capacity (0-100) in Methodology assessment and Rating of statistical capacity (0-100) in Overall level?
Offer a very short reply. -3.33. In the year 2013, what is the difference between the Rating of statistical capacity (0-100) of Methodology assessment and Rating of statistical capacity (0-100) of Periodicity assessment?
Your response must be concise. -10. In the year 2013, what is the difference between the Rating of statistical capacity (0-100) in Overall level and Rating of statistical capacity (0-100) in Periodicity assessment?
Your answer should be very brief. -6.67. In the year 2013, what is the difference between the Rating of statistical capacity (0-100) in Overall level and Rating of statistical capacity (0-100) in Source data assessment?
Your answer should be very brief. 3.33. In the year 2013, what is the difference between the Rating of statistical capacity (0-100) in Periodicity assessment and Rating of statistical capacity (0-100) in Source data assessment?
Your answer should be very brief. 10. What is the ratio of the Rating of statistical capacity (0-100) of Methodology assessment in 2006 to that in 2007?
Ensure brevity in your answer.  1. What is the ratio of the Rating of statistical capacity (0-100) in Overall level in 2006 to that in 2007?
Your answer should be compact. 0.88. What is the ratio of the Rating of statistical capacity (0-100) in Periodicity assessment in 2006 to that in 2007?
Provide a succinct answer. 0.94. What is the ratio of the Rating of statistical capacity (0-100) in Overall level in 2006 to that in 2008?
Offer a terse response. 0.78. What is the ratio of the Rating of statistical capacity (0-100) in Periodicity assessment in 2006 to that in 2008?
Provide a succinct answer. 0.89. What is the ratio of the Rating of statistical capacity (0-100) of Methodology assessment in 2006 to that in 2009?
Ensure brevity in your answer.  1. What is the ratio of the Rating of statistical capacity (0-100) of Overall level in 2006 to that in 2009?
Offer a terse response. 0.78. What is the ratio of the Rating of statistical capacity (0-100) in Periodicity assessment in 2006 to that in 2009?
Keep it short and to the point. 0.89. What is the ratio of the Rating of statistical capacity (0-100) in Source data assessment in 2006 to that in 2009?
Provide a short and direct response. 0.6. What is the ratio of the Rating of statistical capacity (0-100) in Methodology assessment in 2006 to that in 2010?
Your answer should be very brief. 1. What is the ratio of the Rating of statistical capacity (0-100) of Overall level in 2006 to that in 2010?
Your answer should be very brief. 0.78. What is the ratio of the Rating of statistical capacity (0-100) of Periodicity assessment in 2006 to that in 2010?
Ensure brevity in your answer.  0.89. What is the ratio of the Rating of statistical capacity (0-100) of Methodology assessment in 2006 to that in 2011?
Give a very brief answer. 0.5. What is the ratio of the Rating of statistical capacity (0-100) of Overall level in 2006 to that in 2011?
Offer a terse response. 0.69. What is the ratio of the Rating of statistical capacity (0-100) in Periodicity assessment in 2006 to that in 2011?
Keep it short and to the point. 0.81. What is the ratio of the Rating of statistical capacity (0-100) of Source data assessment in 2006 to that in 2011?
Provide a short and direct response. 0.6. What is the ratio of the Rating of statistical capacity (0-100) in Methodology assessment in 2006 to that in 2012?
Your answer should be very brief. 0.2. What is the ratio of the Rating of statistical capacity (0-100) of Overall level in 2006 to that in 2012?
Give a very brief answer. 0.6. What is the ratio of the Rating of statistical capacity (0-100) in Methodology assessment in 2006 to that in 2013?
Provide a short and direct response. 0.2. What is the ratio of the Rating of statistical capacity (0-100) of Overall level in 2006 to that in 2013?
Offer a very short reply. 0.6. What is the ratio of the Rating of statistical capacity (0-100) of Periodicity assessment in 2006 to that in 2013?
Make the answer very short. 0.94. What is the ratio of the Rating of statistical capacity (0-100) in Source data assessment in 2006 to that in 2013?
Your response must be concise. 0.6. What is the ratio of the Rating of statistical capacity (0-100) in Methodology assessment in 2007 to that in 2008?
Keep it short and to the point. 1. What is the ratio of the Rating of statistical capacity (0-100) in Overall level in 2007 to that in 2008?
Offer a very short reply. 0.89. What is the ratio of the Rating of statistical capacity (0-100) of Periodicity assessment in 2007 to that in 2008?
Provide a succinct answer. 0.95. What is the ratio of the Rating of statistical capacity (0-100) of Overall level in 2007 to that in 2009?
Ensure brevity in your answer.  0.89. What is the ratio of the Rating of statistical capacity (0-100) of Periodicity assessment in 2007 to that in 2009?
Provide a succinct answer. 0.95. What is the ratio of the Rating of statistical capacity (0-100) of Source data assessment in 2007 to that in 2009?
Offer a terse response. 0.8. What is the ratio of the Rating of statistical capacity (0-100) in Overall level in 2007 to that in 2010?
Your answer should be compact. 0.89. What is the ratio of the Rating of statistical capacity (0-100) in Periodicity assessment in 2007 to that in 2010?
Keep it short and to the point. 0.95. What is the ratio of the Rating of statistical capacity (0-100) in Overall level in 2007 to that in 2011?
Provide a short and direct response. 0.79. What is the ratio of the Rating of statistical capacity (0-100) in Methodology assessment in 2007 to that in 2012?
Give a very brief answer. 0.2. What is the ratio of the Rating of statistical capacity (0-100) of Overall level in 2007 to that in 2012?
Make the answer very short. 0.69. What is the ratio of the Rating of statistical capacity (0-100) of Source data assessment in 2007 to that in 2012?
Ensure brevity in your answer.  0.8. What is the ratio of the Rating of statistical capacity (0-100) of Methodology assessment in 2007 to that in 2013?
Provide a succinct answer. 0.2. What is the ratio of the Rating of statistical capacity (0-100) in Overall level in 2007 to that in 2013?
Your response must be concise. 0.69. What is the ratio of the Rating of statistical capacity (0-100) in Periodicity assessment in 2007 to that in 2013?
Keep it short and to the point. 1. What is the ratio of the Rating of statistical capacity (0-100) in Overall level in 2008 to that in 2009?
Offer a terse response. 1. What is the ratio of the Rating of statistical capacity (0-100) in Methodology assessment in 2008 to that in 2010?
Provide a succinct answer. 1. What is the ratio of the Rating of statistical capacity (0-100) in Overall level in 2008 to that in 2010?
Keep it short and to the point. 1. What is the ratio of the Rating of statistical capacity (0-100) in Overall level in 2008 to that in 2011?
Keep it short and to the point. 0.88. What is the ratio of the Rating of statistical capacity (0-100) in Periodicity assessment in 2008 to that in 2011?
Provide a short and direct response. 0.9. What is the ratio of the Rating of statistical capacity (0-100) of Overall level in 2008 to that in 2012?
Provide a short and direct response. 0.77. What is the ratio of the Rating of statistical capacity (0-100) in Periodicity assessment in 2008 to that in 2012?
Keep it short and to the point. 1.06. What is the ratio of the Rating of statistical capacity (0-100) of Source data assessment in 2008 to that in 2012?
Ensure brevity in your answer.  1. What is the ratio of the Rating of statistical capacity (0-100) of Methodology assessment in 2008 to that in 2013?
Offer a very short reply. 0.2. What is the ratio of the Rating of statistical capacity (0-100) of Overall level in 2008 to that in 2013?
Ensure brevity in your answer.  0.77. What is the ratio of the Rating of statistical capacity (0-100) in Periodicity assessment in 2008 to that in 2013?
Ensure brevity in your answer.  1.06. What is the ratio of the Rating of statistical capacity (0-100) in Methodology assessment in 2009 to that in 2010?
Your answer should be compact. 1. What is the ratio of the Rating of statistical capacity (0-100) in Overall level in 2009 to that in 2011?
Your response must be concise. 0.88. What is the ratio of the Rating of statistical capacity (0-100) in Periodicity assessment in 2009 to that in 2011?
Your response must be concise. 0.9. What is the ratio of the Rating of statistical capacity (0-100) in Methodology assessment in 2009 to that in 2012?
Make the answer very short. 0.2. What is the ratio of the Rating of statistical capacity (0-100) of Overall level in 2009 to that in 2012?
Ensure brevity in your answer.  0.77. What is the ratio of the Rating of statistical capacity (0-100) in Periodicity assessment in 2009 to that in 2012?
Make the answer very short. 1.06. What is the ratio of the Rating of statistical capacity (0-100) in Source data assessment in 2009 to that in 2012?
Provide a succinct answer. 1. What is the ratio of the Rating of statistical capacity (0-100) in Overall level in 2009 to that in 2013?
Make the answer very short. 0.77. What is the ratio of the Rating of statistical capacity (0-100) in Periodicity assessment in 2009 to that in 2013?
Offer a very short reply. 1.06. What is the ratio of the Rating of statistical capacity (0-100) of Source data assessment in 2009 to that in 2013?
Your answer should be very brief. 1. What is the ratio of the Rating of statistical capacity (0-100) of Methodology assessment in 2010 to that in 2011?
Your response must be concise. 0.5. What is the ratio of the Rating of statistical capacity (0-100) of Overall level in 2010 to that in 2011?
Ensure brevity in your answer.  0.88. What is the ratio of the Rating of statistical capacity (0-100) in Periodicity assessment in 2010 to that in 2011?
Make the answer very short. 0.9. What is the ratio of the Rating of statistical capacity (0-100) of Source data assessment in 2010 to that in 2011?
Keep it short and to the point. 1. What is the ratio of the Rating of statistical capacity (0-100) in Overall level in 2010 to that in 2012?
Keep it short and to the point. 0.77. What is the ratio of the Rating of statistical capacity (0-100) in Periodicity assessment in 2010 to that in 2012?
Your answer should be very brief. 1.06. What is the ratio of the Rating of statistical capacity (0-100) of Methodology assessment in 2010 to that in 2013?
Your answer should be very brief. 0.2. What is the ratio of the Rating of statistical capacity (0-100) of Overall level in 2010 to that in 2013?
Provide a succinct answer. 0.77. What is the ratio of the Rating of statistical capacity (0-100) in Periodicity assessment in 2010 to that in 2013?
Provide a short and direct response. 1.06. What is the ratio of the Rating of statistical capacity (0-100) in Methodology assessment in 2011 to that in 2012?
Ensure brevity in your answer.  0.4. What is the ratio of the Rating of statistical capacity (0-100) of Overall level in 2011 to that in 2012?
Provide a short and direct response. 0.88. What is the ratio of the Rating of statistical capacity (0-100) of Methodology assessment in 2011 to that in 2013?
Provide a short and direct response. 0.4. What is the ratio of the Rating of statistical capacity (0-100) in Periodicity assessment in 2011 to that in 2013?
Make the answer very short. 1.17. What is the ratio of the Rating of statistical capacity (0-100) of Source data assessment in 2012 to that in 2013?
Provide a succinct answer. 1. What is the difference between the highest and the second highest Rating of statistical capacity (0-100) of Periodicity assessment?
Keep it short and to the point. 6.67. What is the difference between the highest and the lowest Rating of statistical capacity (0-100) in Overall level?
Give a very brief answer. 21.11. What is the difference between the highest and the lowest Rating of statistical capacity (0-100) in Periodicity assessment?
Offer a terse response. 13.33. 